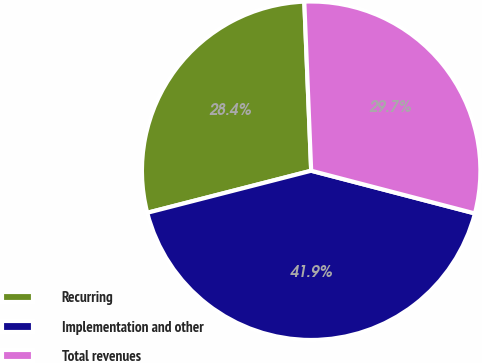Convert chart to OTSL. <chart><loc_0><loc_0><loc_500><loc_500><pie_chart><fcel>Recurring<fcel>Implementation and other<fcel>Total revenues<nl><fcel>28.35%<fcel>41.94%<fcel>29.71%<nl></chart> 